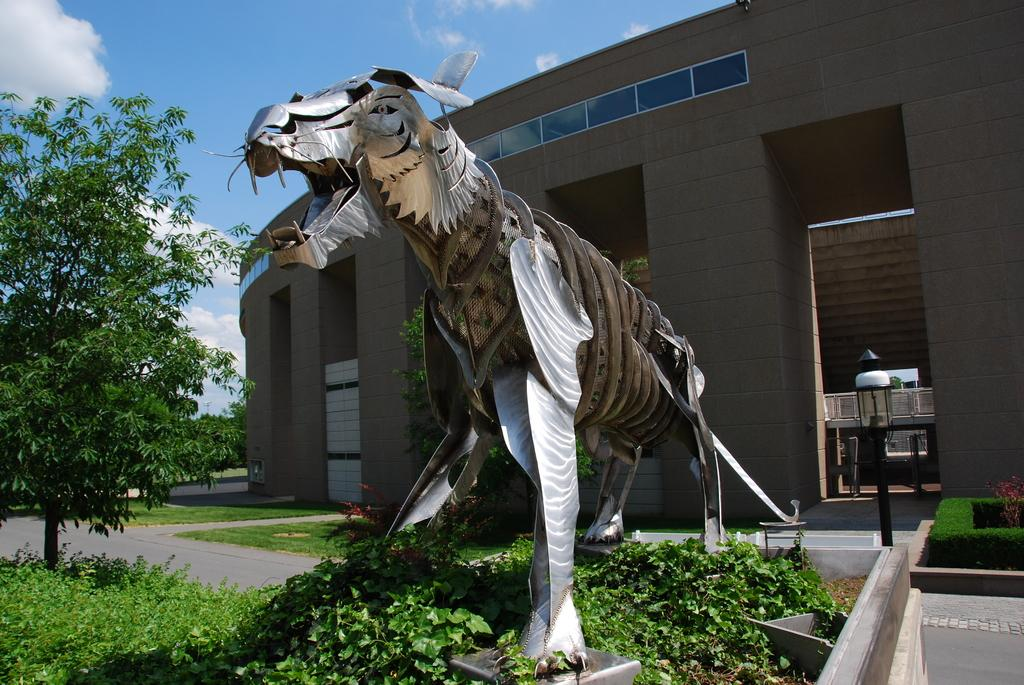What type of structure is visible in the image? There is a building in the image. Can you describe any additional features near the building? There is a statue of an animal in front of the building. What can be seen in the surrounding area of the building? There is a lot of greenery around the building. Where is the stove located in the image? There is no stove present in the image. How does the animal's digestion process work in the image? The image does not depict the animal's digestion process; it only shows a statue of an animal. 